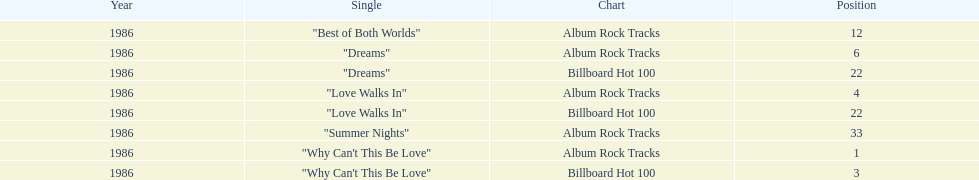Which singles each appear at position 22? Dreams, Love Walks In. 